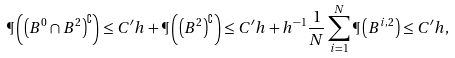<formula> <loc_0><loc_0><loc_500><loc_500>\P \left ( \left ( B ^ { 0 } \cap B ^ { 2 } \right ) ^ { \complement } \right ) & \leq C ^ { \prime } h + \P \left ( \left ( B ^ { 2 } \right ) ^ { \complement } \right ) \leq C ^ { \prime } h + h ^ { - 1 } \frac { 1 } { N } \sum _ { i = 1 } ^ { N } \P \left ( B ^ { i , 2 } \right ) \leq C ^ { \prime } h ,</formula> 